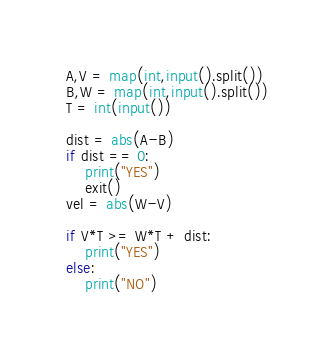<code> <loc_0><loc_0><loc_500><loc_500><_Python_>A,V = map(int,input().split())
B,W = map(int,input().split())
T = int(input())

dist = abs(A-B)
if dist == 0:
    print("YES")
    exit()
vel = abs(W-V)

if V*T >= W*T + dist:
    print("YES")
else:
    print("NO")
</code> 